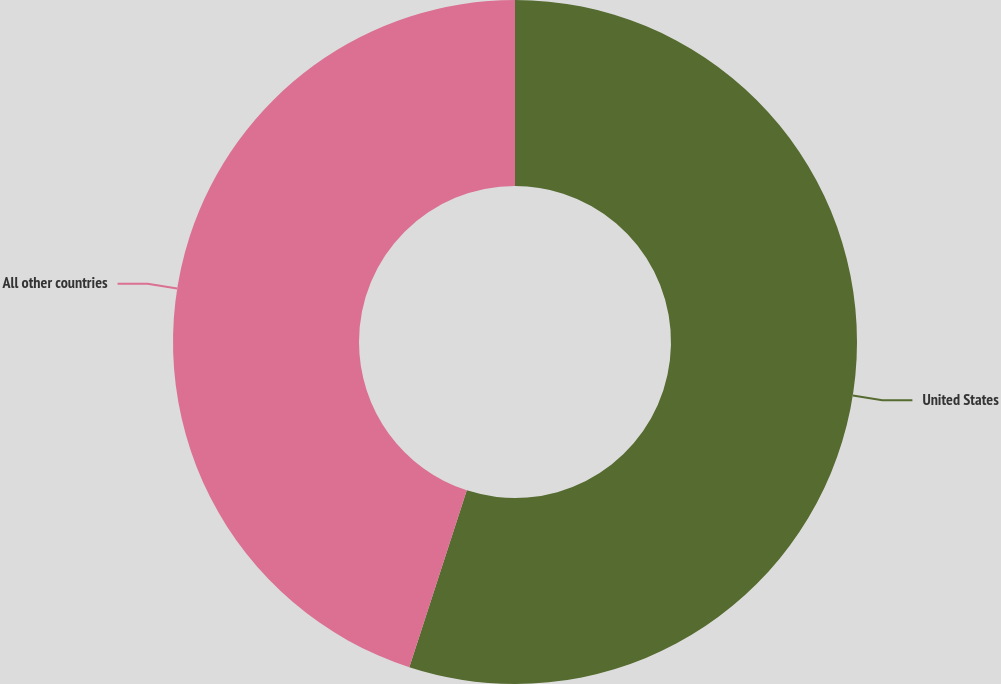Convert chart to OTSL. <chart><loc_0><loc_0><loc_500><loc_500><pie_chart><fcel>United States<fcel>All other countries<nl><fcel>55.0%<fcel>45.0%<nl></chart> 